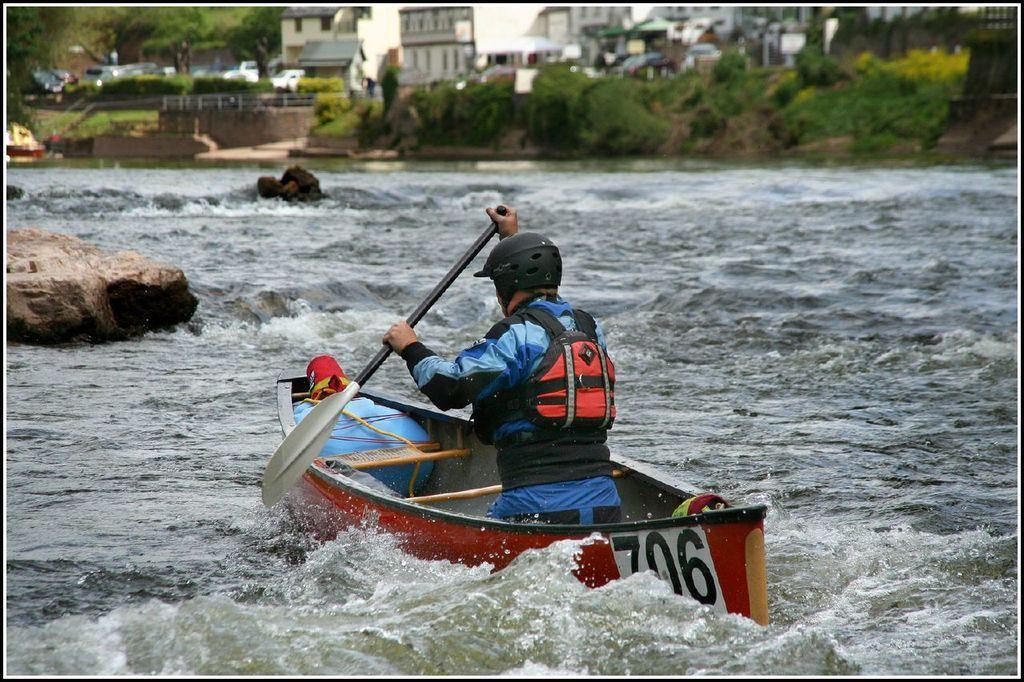Describe this image in one or two sentences. In this picture we can see a person on a boat and this boat is on water and in the background we can see buildings with windows. 